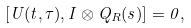<formula> <loc_0><loc_0><loc_500><loc_500>[ U ( t , \tau ) , I \otimes Q _ { R } ( s ) ] = 0 ,</formula> 